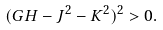<formula> <loc_0><loc_0><loc_500><loc_500>( G H - J ^ { 2 } - K ^ { 2 } ) ^ { 2 } > 0 .</formula> 